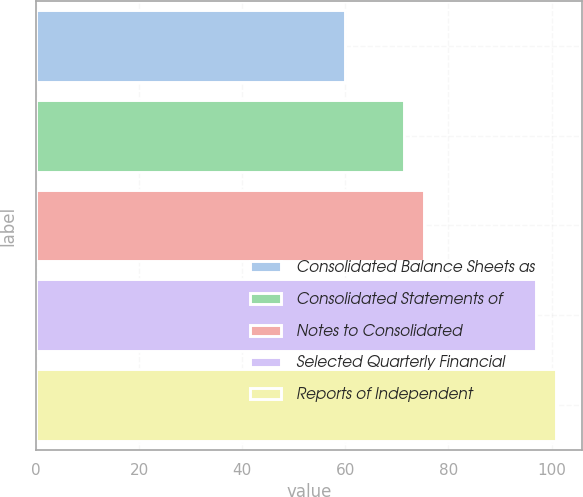Convert chart to OTSL. <chart><loc_0><loc_0><loc_500><loc_500><bar_chart><fcel>Consolidated Balance Sheets as<fcel>Consolidated Statements of<fcel>Notes to Consolidated<fcel>Selected Quarterly Financial<fcel>Reports of Independent<nl><fcel>60<fcel>71.4<fcel>75.2<fcel>97<fcel>100.8<nl></chart> 